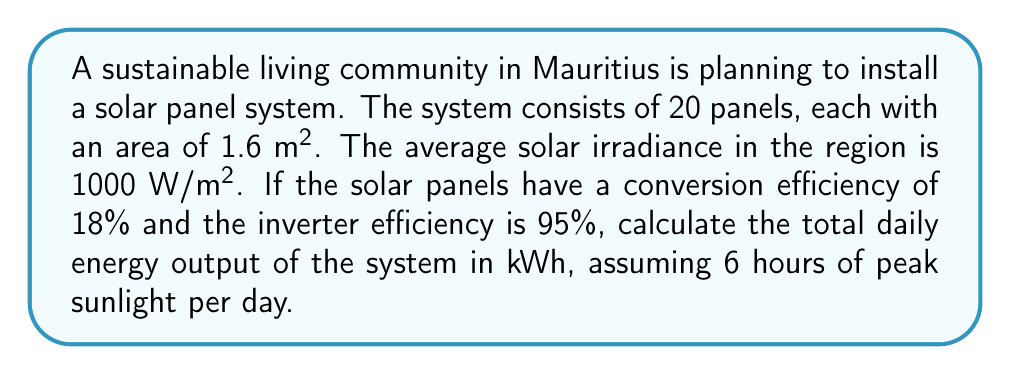What is the answer to this math problem? Let's break this down step-by-step:

1) First, calculate the total area of the solar panels:
   $$A_{total} = 20 \times 1.6 \text{ m}^2 = 32 \text{ m}^2$$

2) The power input from the sun is:
   $$P_{input} = \text{Irradiance} \times A_{total}$$
   $$P_{input} = 1000 \text{ W/m}^2 \times 32 \text{ m}^2 = 32000 \text{ W} = 32 \text{ kW}$$

3) The power output of the solar panels, considering their efficiency:
   $$P_{panels} = P_{input} \times \text{Panel Efficiency}$$
   $$P_{panels} = 32 \text{ kW} \times 0.18 = 5.76 \text{ kW}$$

4) The final power output, considering inverter efficiency:
   $$P_{output} = P_{panels} \times \text{Inverter Efficiency}$$
   $$P_{output} = 5.76 \text{ kW} \times 0.95 = 5.472 \text{ kW}$$

5) To calculate the daily energy output, multiply by the number of peak sunlight hours:
   $$E_{daily} = P_{output} \times \text{Peak Sunlight Hours}$$
   $$E_{daily} = 5.472 \text{ kW} \times 6 \text{ hours} = 32.832 \text{ kWh}$$

Therefore, the total daily energy output of the system is approximately 32.832 kWh.
Answer: 32.832 kWh 